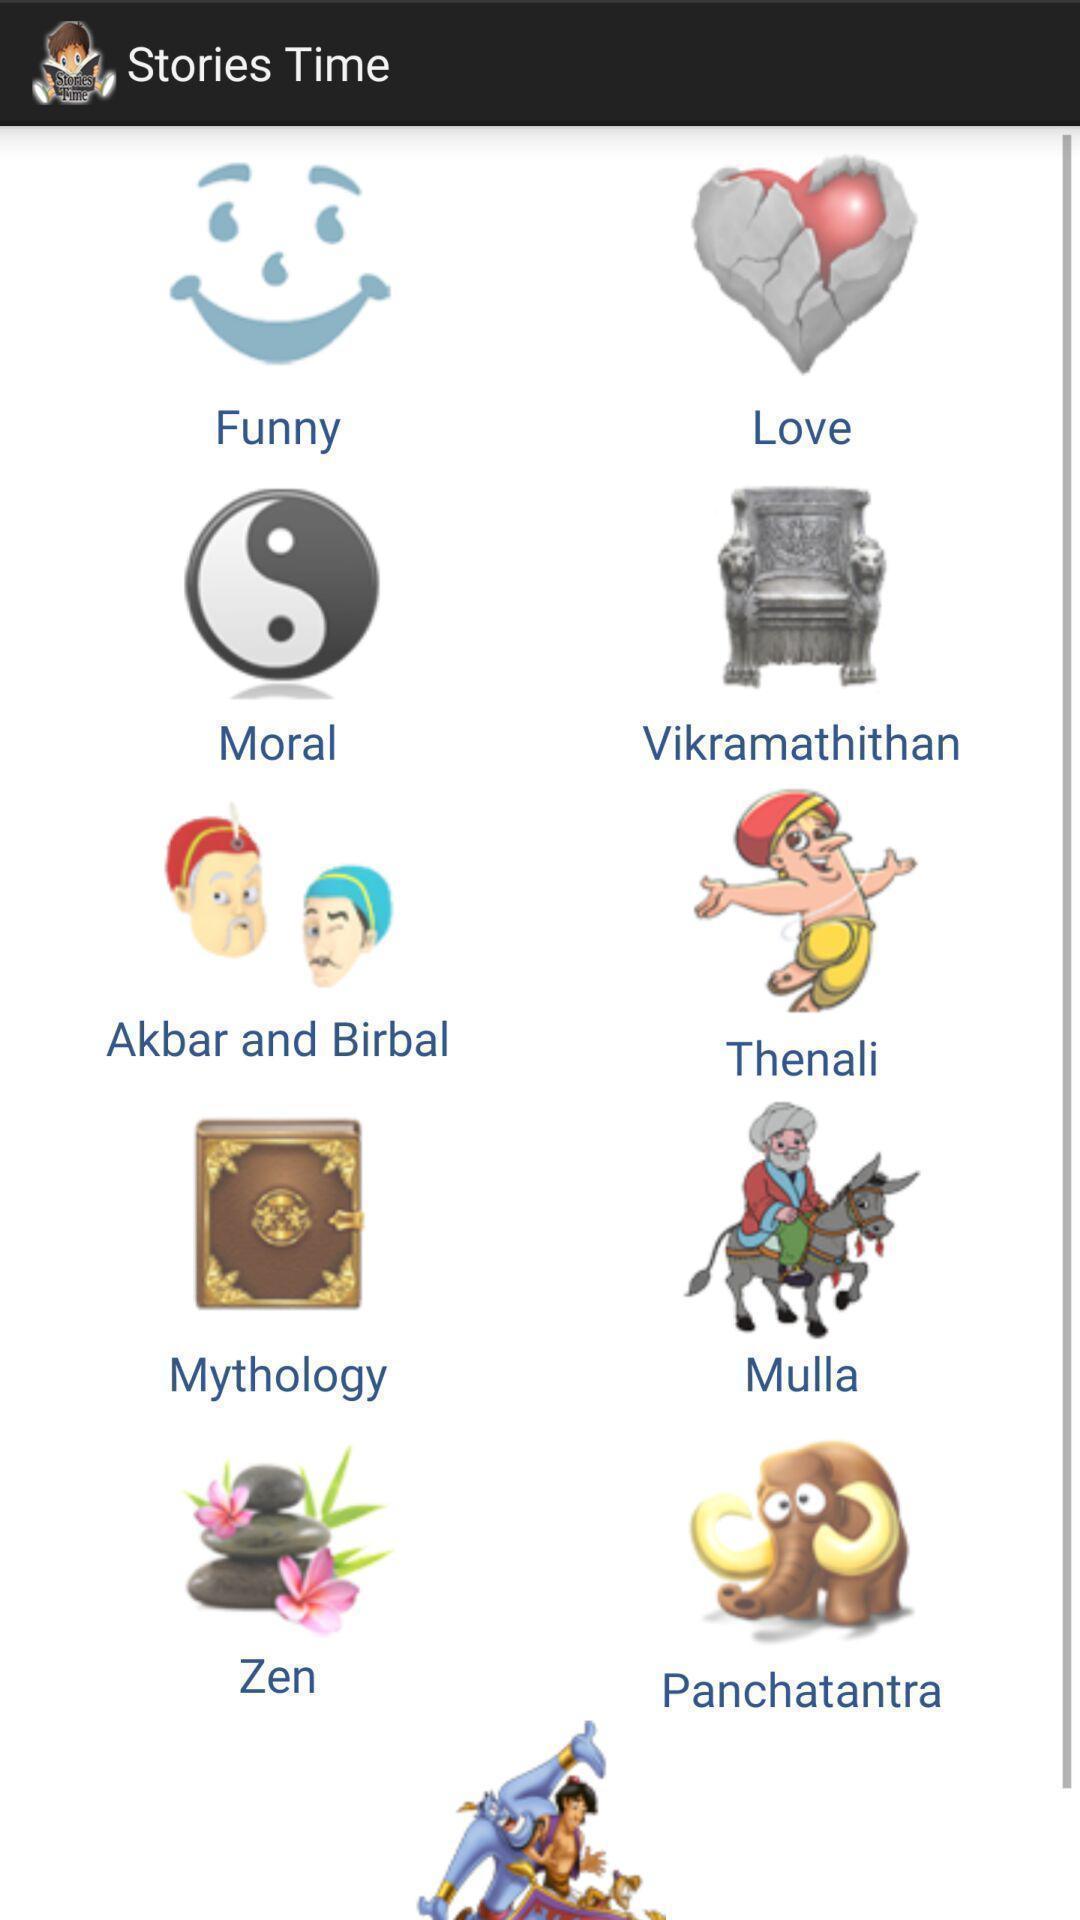Give me a summary of this screen capture. Screen shows categories of stories for all age groups. 